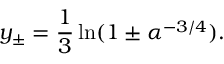Convert formula to latex. <formula><loc_0><loc_0><loc_500><loc_500>y _ { \pm } = \frac { 1 } { 3 } \ln ( 1 \pm \alpha ^ { - 3 / 4 } ) .</formula> 